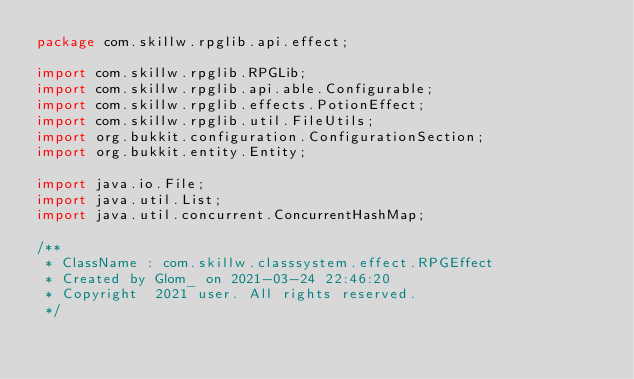<code> <loc_0><loc_0><loc_500><loc_500><_Java_>package com.skillw.rpglib.api.effect;

import com.skillw.rpglib.RPGLib;
import com.skillw.rpglib.api.able.Configurable;
import com.skillw.rpglib.effects.PotionEffect;
import com.skillw.rpglib.util.FileUtils;
import org.bukkit.configuration.ConfigurationSection;
import org.bukkit.entity.Entity;

import java.io.File;
import java.util.List;
import java.util.concurrent.ConcurrentHashMap;

/**
 * ClassName : com.skillw.classsystem.effect.RPGEffect
 * Created by Glom_ on 2021-03-24 22:46:20
 * Copyright  2021 user. All rights reserved.
 */</code> 